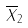Convert formula to latex. <formula><loc_0><loc_0><loc_500><loc_500>\overline { X } _ { 2 }</formula> 